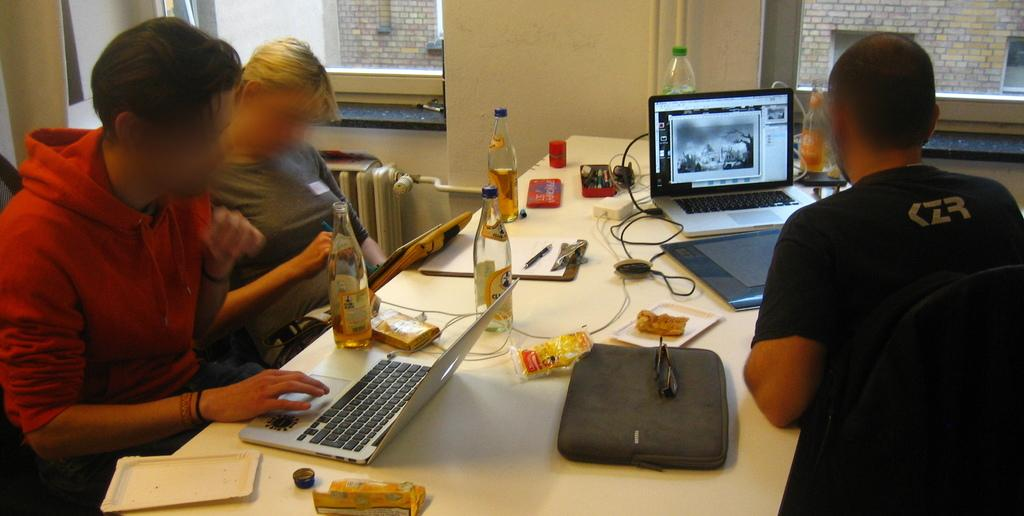Provide a one-sentence caption for the provided image. people at  a shared desk and one worker's shirt reads KZR. 